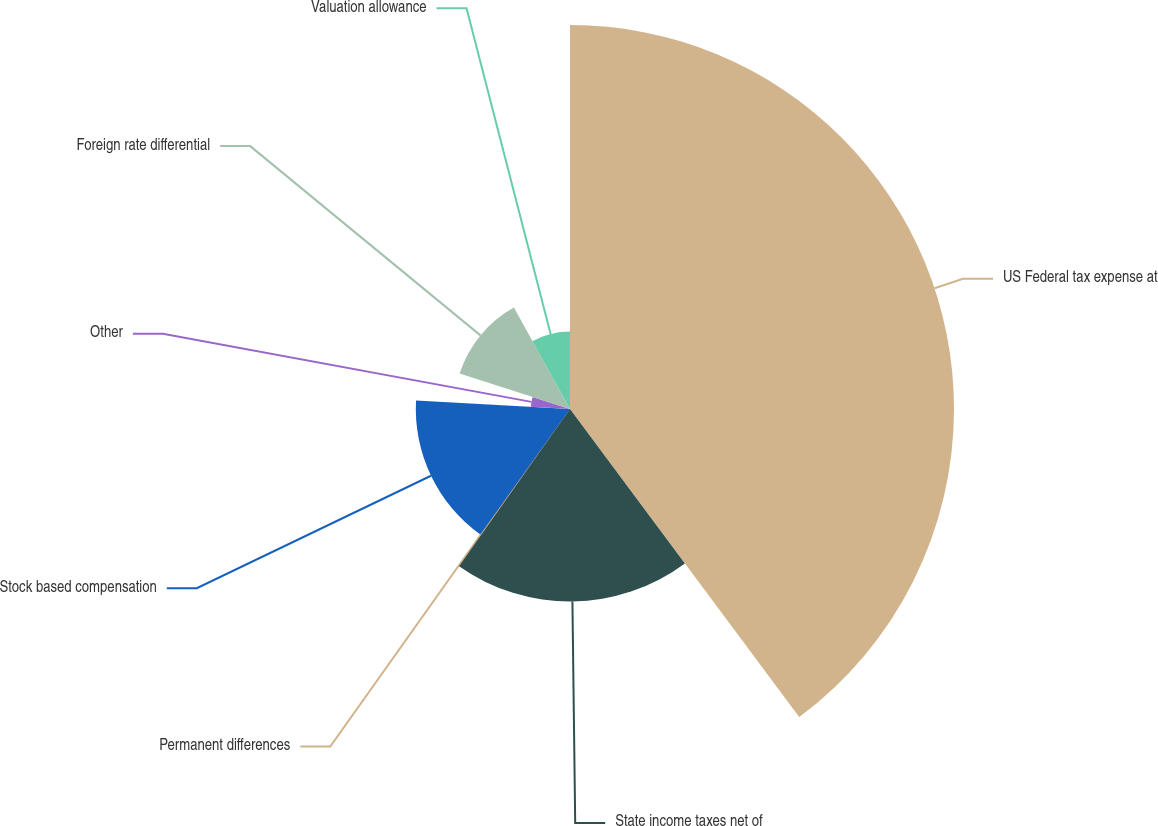Convert chart. <chart><loc_0><loc_0><loc_500><loc_500><pie_chart><fcel>US Federal tax expense at<fcel>State income taxes net of<fcel>Permanent differences<fcel>Stock based compensation<fcel>Other<fcel>Foreign rate differential<fcel>Valuation allowance<nl><fcel>39.82%<fcel>19.96%<fcel>0.1%<fcel>15.99%<fcel>4.07%<fcel>12.02%<fcel>8.04%<nl></chart> 